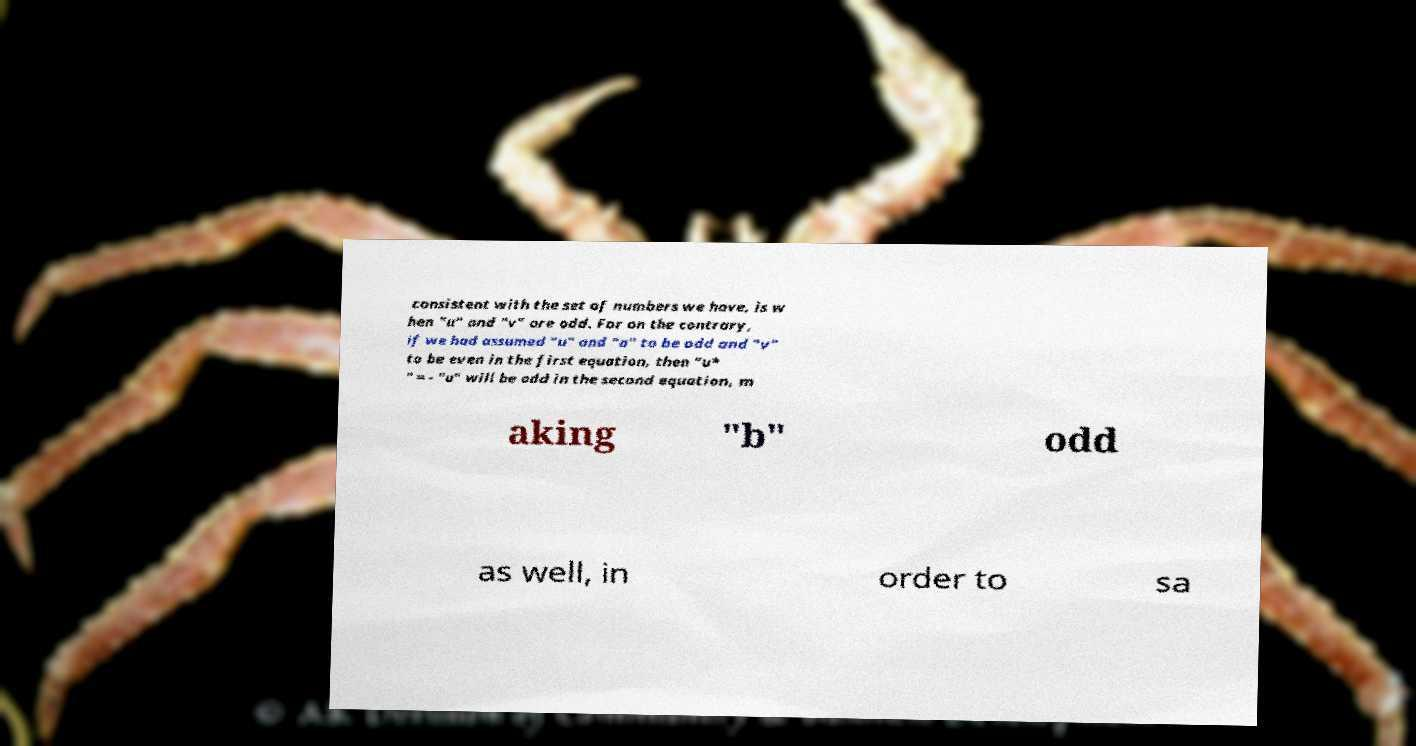Please identify and transcribe the text found in this image. consistent with the set of numbers we have, is w hen "u" and "v" are odd. For on the contrary, if we had assumed "u" and "a" to be odd and "v" to be even in the first equation, then "u* " = - "u" will be odd in the second equation, m aking "b" odd as well, in order to sa 